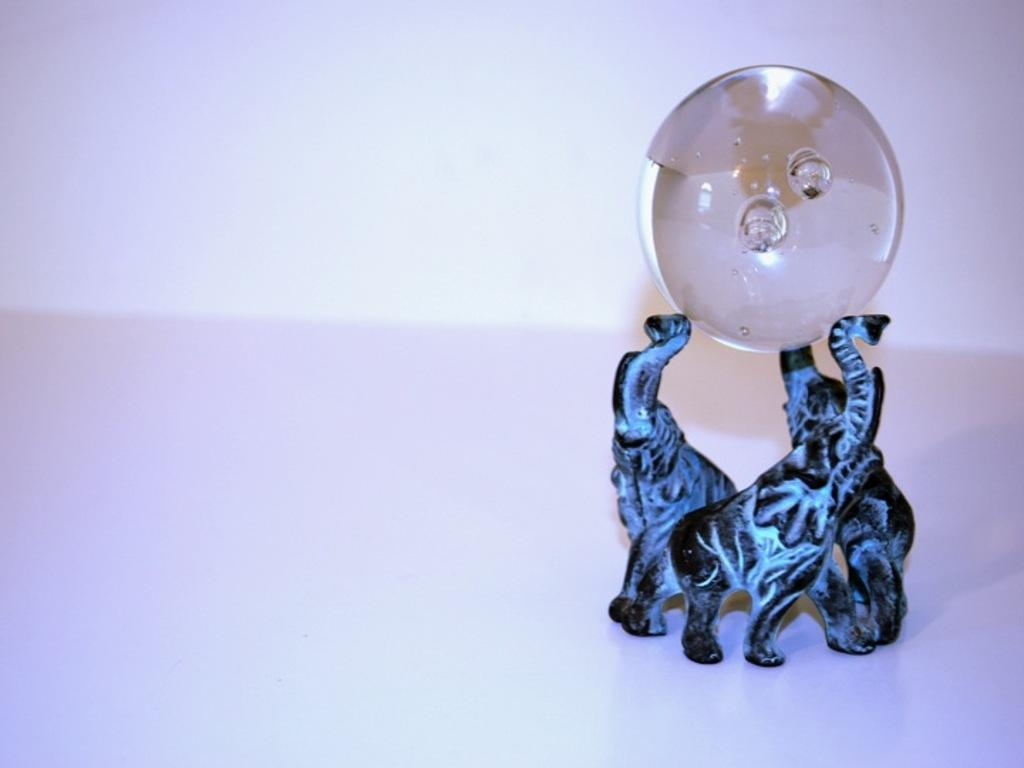What is the main subject of the image? There is a sculpture in the image. What is the sculpture holding? The sculpture is holding a circular object. What color is the background of the image? The background of the image is white. What type of hose is being used by the sculpture in the image? There is no hose present in the image; the sculpture is holding a circular object. What breed of dog can be seen interacting with the sculpture in the image? There is no dog present in the image; the main subject is the sculpture holding a circular object. 